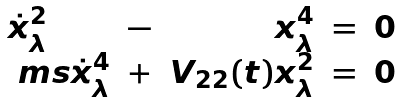<formula> <loc_0><loc_0><loc_500><loc_500>\begin{array} { l l r l l } \dot { x } ^ { 2 } _ { \lambda } & - & x ^ { 4 } _ { \lambda } & = & 0 \\ { \ m s } \dot { x } ^ { 4 } _ { \lambda } & + & V _ { 2 2 } ( t ) x ^ { 2 } _ { \lambda } & = & 0 \\ \end{array}</formula> 